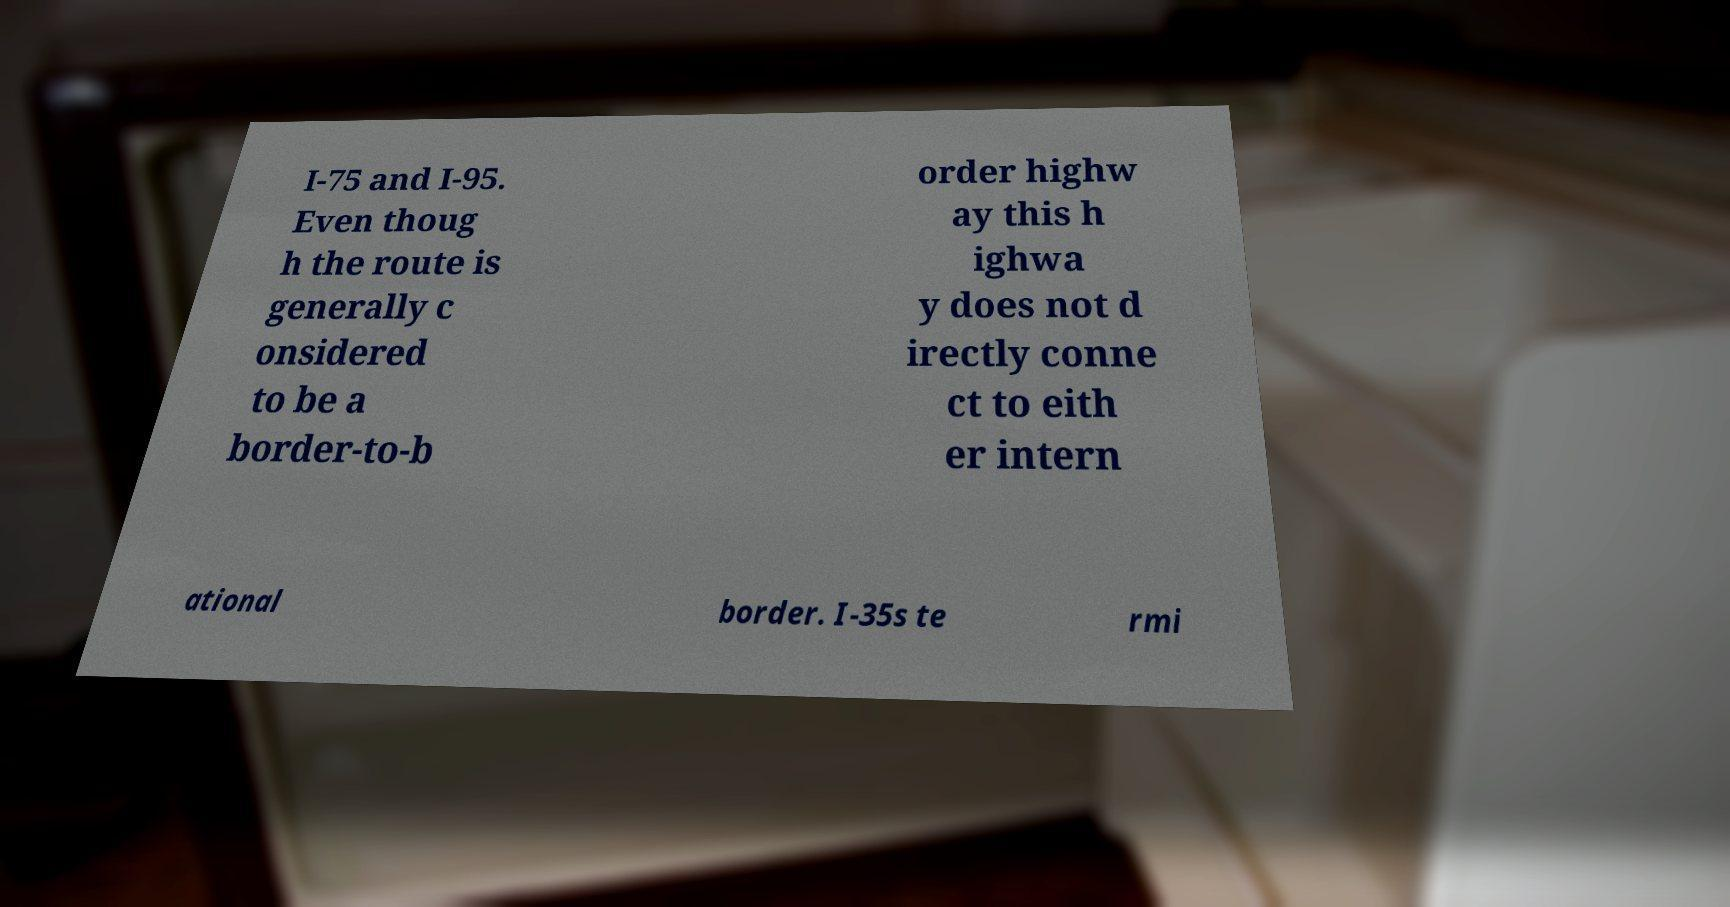Could you extract and type out the text from this image? I-75 and I-95. Even thoug h the route is generally c onsidered to be a border-to-b order highw ay this h ighwa y does not d irectly conne ct to eith er intern ational border. I-35s te rmi 